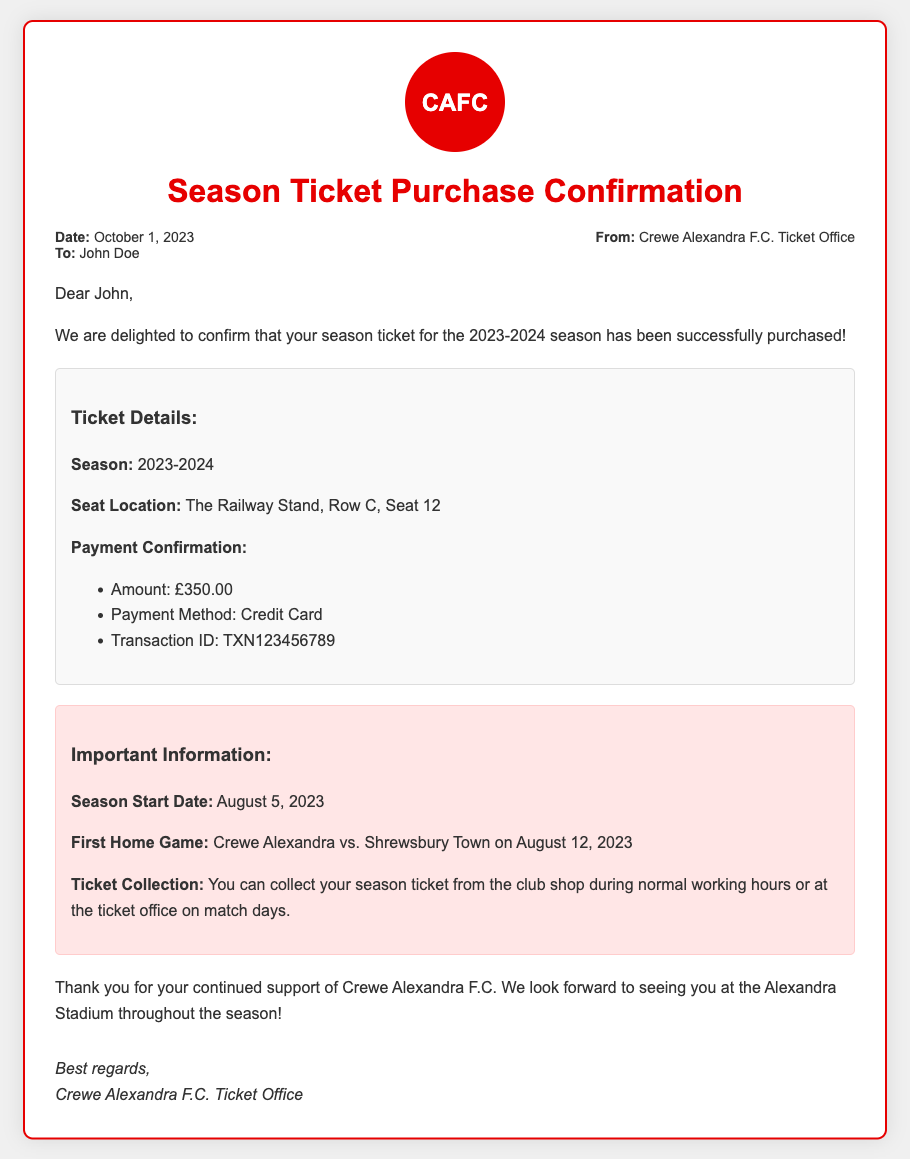What is the date of the memo? The date is provided in the meta section of the document.
Answer: October 1, 2023 Who is the recipient of the memo? The recipient's name is stated in the meta section.
Answer: John Doe What is the seat location for the season ticket? The seat location is detailed in the ticket details section.
Answer: The Railway Stand, Row C, Seat 12 What is the payment amount for the season ticket? The payment amount is specified in the payment confirmation under ticket details.
Answer: £350.00 What is the transaction ID? The transaction ID is provided in the payment confirmation section.
Answer: TXN123456789 When does the season start? The season start date is mentioned in the important information section.
Answer: August 5, 2023 What is the first home game? The first home game is detailed in the important information section.
Answer: Crewe Alexandra vs. Shrewsbury Town on August 12, 2023 Where can the season ticket be collected? The collection locations are specified in the important information section.
Answer: Club shop or ticket office on match days What does CAFC stand for? The acronym CAFC is shown in the logo section of the memo.
Answer: Crewe Alexandra F.C 